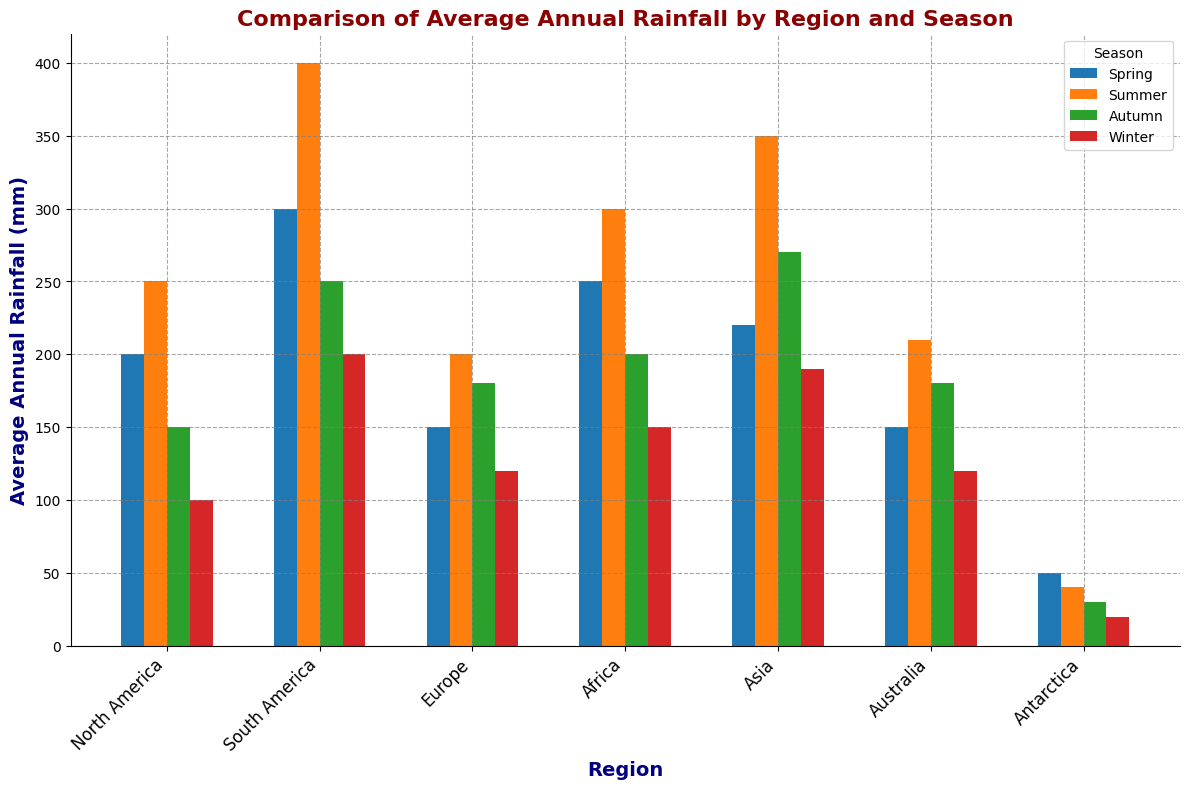What's the region with the highest average annual rainfall in the Summer? In the Summer, compare the heights of the bars across all regions. South America has the highest bar in summer.
Answer: South America Which season has the lowest average annual rainfall in Antarctica? Compare the heights of the four seasonal bars for Antarctica. Winter has the shortest bar.
Answer: Winter What's the difference in average annual rainfall between Spring and Autumn in Asia? Look at the bars for Asia in Spring (220 mm) and Autumn (270 mm). The difference is 270 - 220.
Answer: 50 mm Which regions receive more average annual rainfall in Autumn compared to Winter? Compare the Autumn and Winter bars for each region. South America, Europe, Africa, Asia, and Australia all show higher rainfall in Autumn than in Winter.
Answer: South America, Europe, Africa, Asia, Australia What's the sum of the average annual rainfall in Winter across all regions? Sum the heights of the bars for Winter across all regions. 100 (NA) + 200 (SA) + 120 (EU) + 150 (AF) + 190 (AS) + 120 (AU) + 20 (AN) = 900 mm.
Answer: 900 mm How does the average annual rainfall in Spring in Africa compare to that in North America? Compare the Spring bar heights for Africa (250 mm) and North America (200 mm). Africa receives more rainfall.
Answer: Africa receives more Which season shows the most significant rainfall difference between the regions with the highest and lowest values? Compare the range of bar heights for each season. Summer has the maximum difference (400 mm in SA - 40 mm in AN).
Answer: Summer What is the average annual rainfall in Europe for all seasons? Calculate the average from Spring (150 mm), Summer (200 mm), Autumn (180 mm), and Winter (120 mm). (150 + 200 + 180 + 120) / 4 = 650 / 4 = 162.5 mm.
Answer: 162.5 mm What's the ratio of the highest average annual rainfall to the lowest average annual rainfall for all regions and seasons? The highest is 400 mm (Summer in SA) and the lowest is 20 mm (Winter in AN). The ratio is 400 / 20.
Answer: 20:1 